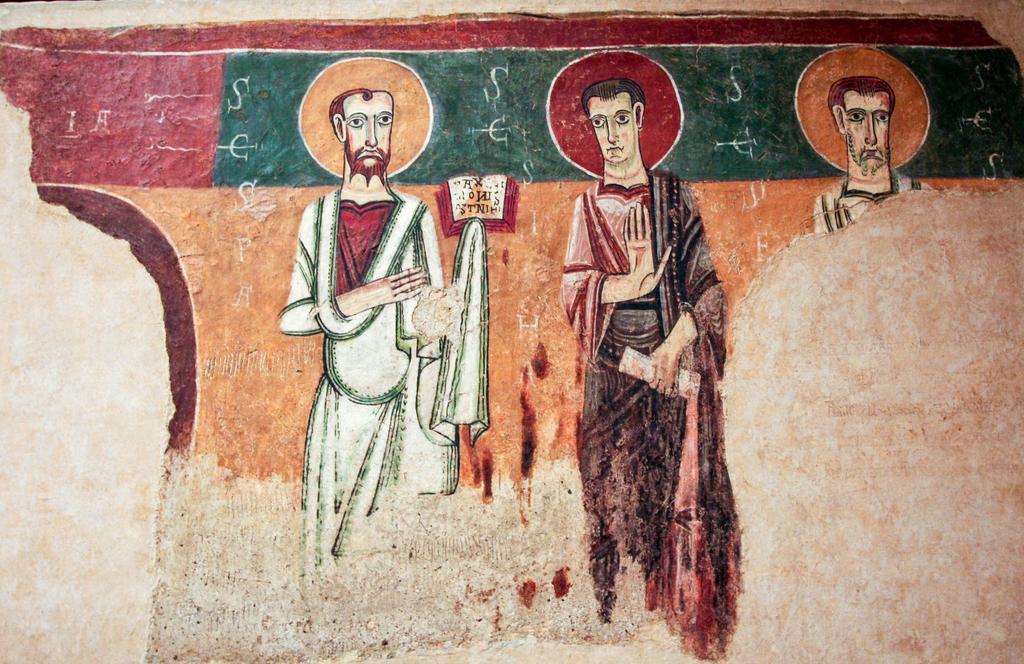Could you give a brief overview of what you see in this image? In this image I can see depiction painting of people on the wall. I can also see many colors in this painting. 